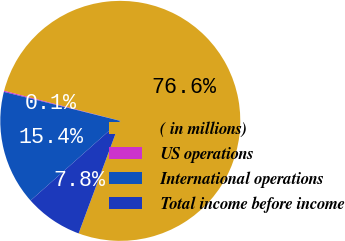Convert chart. <chart><loc_0><loc_0><loc_500><loc_500><pie_chart><fcel>( in millions)<fcel>US operations<fcel>International operations<fcel>Total income before income<nl><fcel>76.61%<fcel>0.15%<fcel>15.44%<fcel>7.8%<nl></chart> 